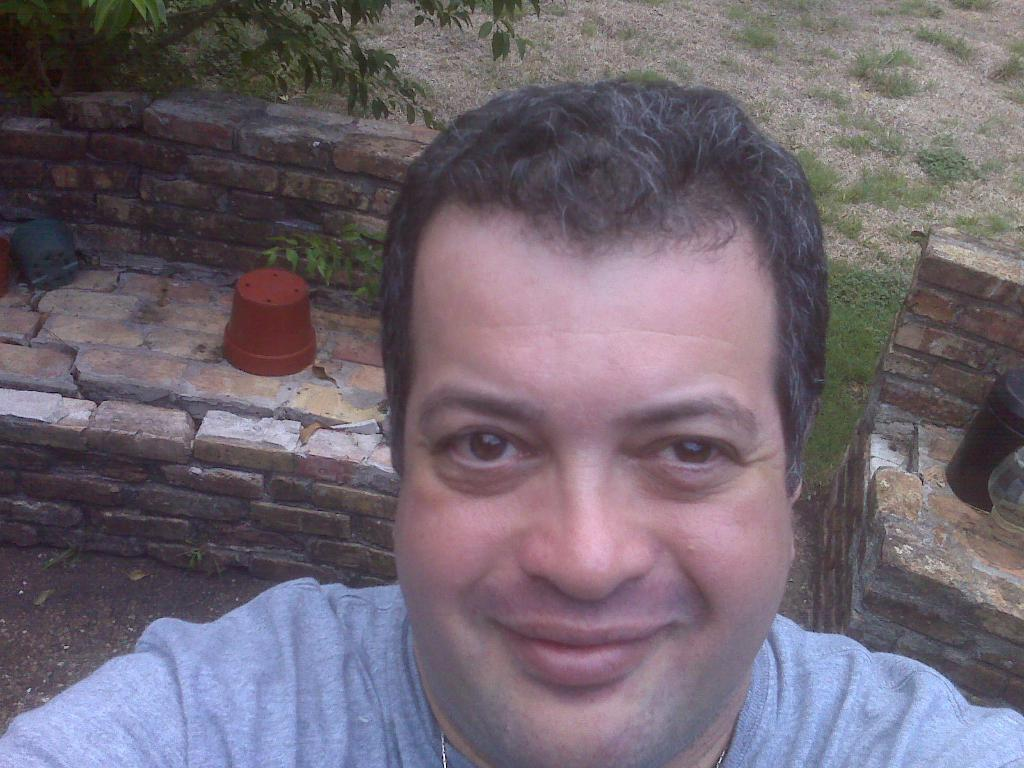Who is the main subject in the image? There is a man in the center of the image. What can be seen in the background of the image? There are plant pots, walls, and a tree in the background of the image. How many bears are visible in the image? There are no bears present in the image. What is the man doing with his foot in the image? The image does not show the man's feet or any actions involving his foot. 